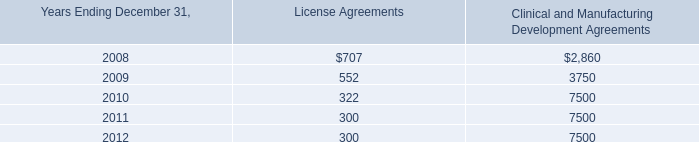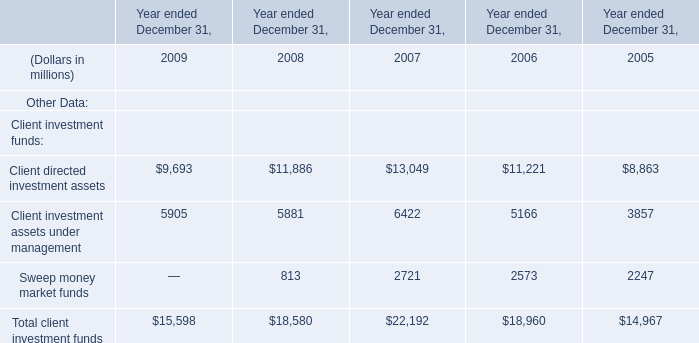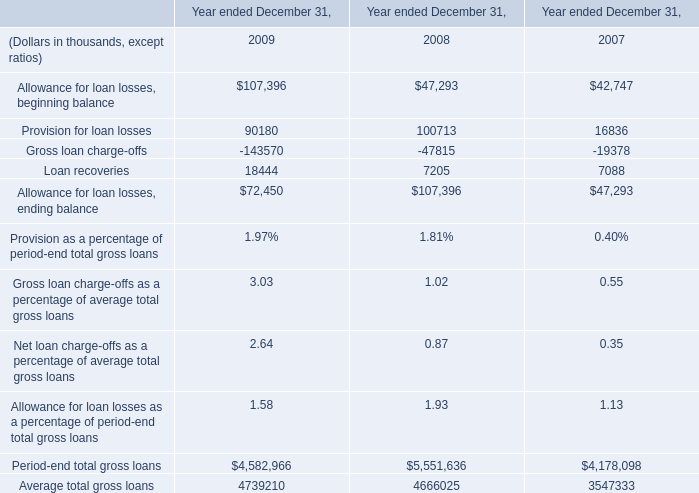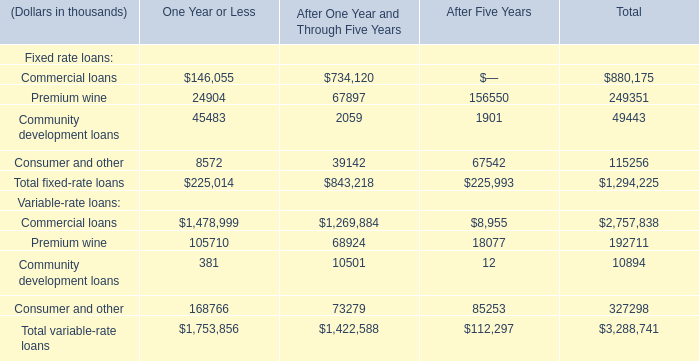As As the chart 3 shows,what is the Total variable-rate loans for After One Year and Through Five Years? (in thousand) 
Answer: 1422588. 